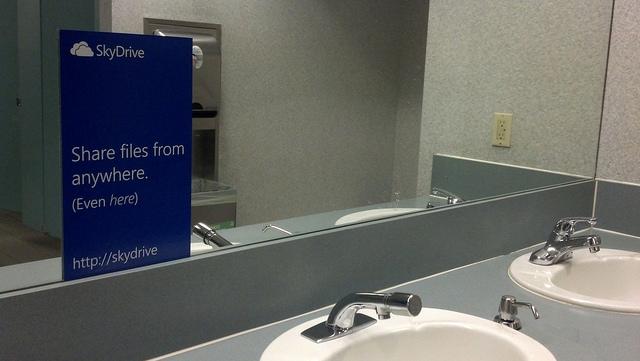Is the bathroom clean?
Give a very brief answer. Yes. Would this be a farmhouse?
Keep it brief. No. What color are the taps?
Short answer required. Silver. Does the bathroom have wifi?
Give a very brief answer. Yes. 